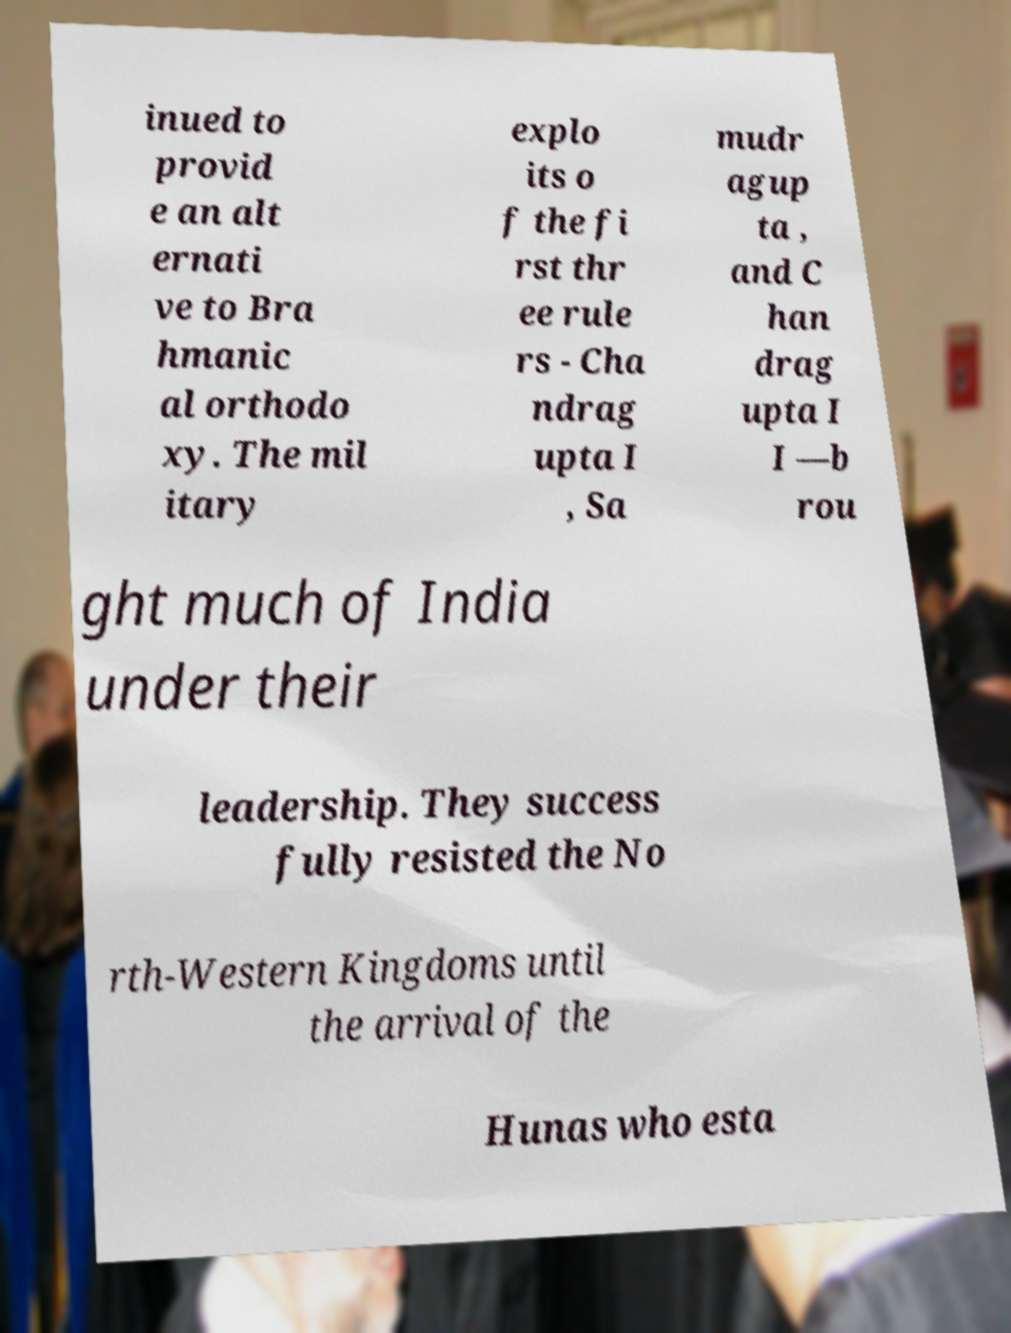Could you assist in decoding the text presented in this image and type it out clearly? inued to provid e an alt ernati ve to Bra hmanic al orthodo xy. The mil itary explo its o f the fi rst thr ee rule rs - Cha ndrag upta I , Sa mudr agup ta , and C han drag upta I I —b rou ght much of India under their leadership. They success fully resisted the No rth-Western Kingdoms until the arrival of the Hunas who esta 